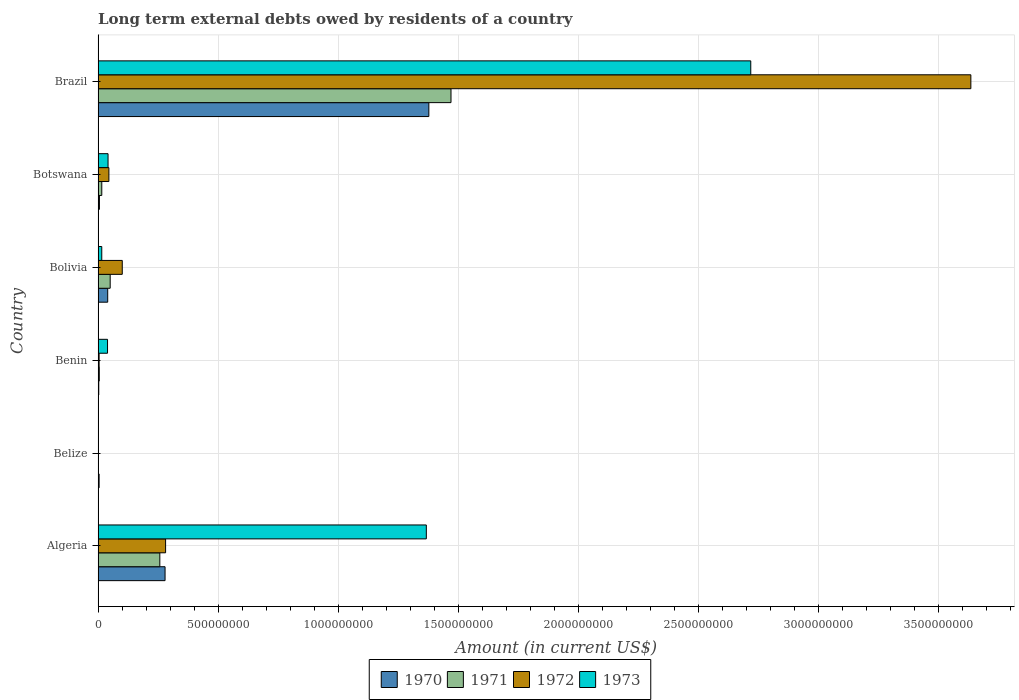Are the number of bars on each tick of the Y-axis equal?
Ensure brevity in your answer.  No. What is the label of the 4th group of bars from the top?
Your response must be concise. Benin. What is the amount of long-term external debts owed by residents in 1972 in Bolivia?
Your answer should be compact. 1.01e+08. Across all countries, what is the maximum amount of long-term external debts owed by residents in 1973?
Your answer should be very brief. 2.72e+09. What is the total amount of long-term external debts owed by residents in 1973 in the graph?
Your answer should be very brief. 4.18e+09. What is the difference between the amount of long-term external debts owed by residents in 1970 in Benin and that in Botswana?
Ensure brevity in your answer.  -2.70e+06. What is the difference between the amount of long-term external debts owed by residents in 1971 in Bolivia and the amount of long-term external debts owed by residents in 1972 in Algeria?
Ensure brevity in your answer.  -2.31e+08. What is the average amount of long-term external debts owed by residents in 1971 per country?
Offer a very short reply. 2.99e+08. What is the difference between the amount of long-term external debts owed by residents in 1970 and amount of long-term external debts owed by residents in 1971 in Benin?
Offer a terse response. -2.12e+06. What is the ratio of the amount of long-term external debts owed by residents in 1973 in Algeria to that in Benin?
Offer a very short reply. 34.74. What is the difference between the highest and the second highest amount of long-term external debts owed by residents in 1972?
Your response must be concise. 3.35e+09. What is the difference between the highest and the lowest amount of long-term external debts owed by residents in 1972?
Offer a very short reply. 3.63e+09. Is the sum of the amount of long-term external debts owed by residents in 1970 in Bolivia and Brazil greater than the maximum amount of long-term external debts owed by residents in 1972 across all countries?
Ensure brevity in your answer.  No. Is it the case that in every country, the sum of the amount of long-term external debts owed by residents in 1973 and amount of long-term external debts owed by residents in 1972 is greater than the sum of amount of long-term external debts owed by residents in 1970 and amount of long-term external debts owed by residents in 1971?
Offer a very short reply. No. Is it the case that in every country, the sum of the amount of long-term external debts owed by residents in 1973 and amount of long-term external debts owed by residents in 1970 is greater than the amount of long-term external debts owed by residents in 1972?
Your answer should be compact. No. How many bars are there?
Make the answer very short. 21. Are all the bars in the graph horizontal?
Make the answer very short. Yes. How many countries are there in the graph?
Provide a short and direct response. 6. What is the difference between two consecutive major ticks on the X-axis?
Provide a succinct answer. 5.00e+08. Does the graph contain any zero values?
Offer a very short reply. Yes. Where does the legend appear in the graph?
Make the answer very short. Bottom center. How many legend labels are there?
Provide a succinct answer. 4. What is the title of the graph?
Give a very brief answer. Long term external debts owed by residents of a country. What is the label or title of the X-axis?
Offer a terse response. Amount (in current US$). What is the label or title of the Y-axis?
Keep it short and to the point. Country. What is the Amount (in current US$) of 1970 in Algeria?
Give a very brief answer. 2.79e+08. What is the Amount (in current US$) of 1971 in Algeria?
Ensure brevity in your answer.  2.57e+08. What is the Amount (in current US$) in 1972 in Algeria?
Give a very brief answer. 2.81e+08. What is the Amount (in current US$) in 1973 in Algeria?
Provide a succinct answer. 1.37e+09. What is the Amount (in current US$) in 1970 in Belize?
Provide a succinct answer. 4.30e+06. What is the Amount (in current US$) of 1973 in Belize?
Your answer should be very brief. 0. What is the Amount (in current US$) in 1970 in Benin?
Keep it short and to the point. 2.87e+06. What is the Amount (in current US$) in 1971 in Benin?
Offer a terse response. 4.99e+06. What is the Amount (in current US$) in 1972 in Benin?
Your answer should be compact. 4.28e+06. What is the Amount (in current US$) of 1973 in Benin?
Your response must be concise. 3.93e+07. What is the Amount (in current US$) of 1970 in Bolivia?
Ensure brevity in your answer.  4.01e+07. What is the Amount (in current US$) in 1971 in Bolivia?
Provide a succinct answer. 5.04e+07. What is the Amount (in current US$) in 1972 in Bolivia?
Ensure brevity in your answer.  1.01e+08. What is the Amount (in current US$) in 1973 in Bolivia?
Make the answer very short. 1.53e+07. What is the Amount (in current US$) of 1970 in Botswana?
Provide a succinct answer. 5.57e+06. What is the Amount (in current US$) of 1971 in Botswana?
Offer a terse response. 1.54e+07. What is the Amount (in current US$) of 1972 in Botswana?
Offer a terse response. 4.50e+07. What is the Amount (in current US$) of 1973 in Botswana?
Make the answer very short. 4.15e+07. What is the Amount (in current US$) in 1970 in Brazil?
Your answer should be very brief. 1.38e+09. What is the Amount (in current US$) of 1971 in Brazil?
Provide a short and direct response. 1.47e+09. What is the Amount (in current US$) of 1972 in Brazil?
Your answer should be very brief. 3.63e+09. What is the Amount (in current US$) of 1973 in Brazil?
Your response must be concise. 2.72e+09. Across all countries, what is the maximum Amount (in current US$) in 1970?
Your answer should be very brief. 1.38e+09. Across all countries, what is the maximum Amount (in current US$) in 1971?
Give a very brief answer. 1.47e+09. Across all countries, what is the maximum Amount (in current US$) in 1972?
Your answer should be very brief. 3.63e+09. Across all countries, what is the maximum Amount (in current US$) in 1973?
Your answer should be very brief. 2.72e+09. Across all countries, what is the minimum Amount (in current US$) of 1970?
Keep it short and to the point. 2.87e+06. Across all countries, what is the minimum Amount (in current US$) in 1972?
Keep it short and to the point. 0. Across all countries, what is the minimum Amount (in current US$) of 1973?
Your answer should be compact. 0. What is the total Amount (in current US$) of 1970 in the graph?
Keep it short and to the point. 1.71e+09. What is the total Amount (in current US$) in 1971 in the graph?
Provide a succinct answer. 1.80e+09. What is the total Amount (in current US$) of 1972 in the graph?
Provide a short and direct response. 4.06e+09. What is the total Amount (in current US$) of 1973 in the graph?
Offer a very short reply. 4.18e+09. What is the difference between the Amount (in current US$) of 1970 in Algeria and that in Belize?
Keep it short and to the point. 2.74e+08. What is the difference between the Amount (in current US$) in 1970 in Algeria and that in Benin?
Your answer should be very brief. 2.76e+08. What is the difference between the Amount (in current US$) of 1971 in Algeria and that in Benin?
Your answer should be very brief. 2.52e+08. What is the difference between the Amount (in current US$) in 1972 in Algeria and that in Benin?
Your answer should be compact. 2.77e+08. What is the difference between the Amount (in current US$) in 1973 in Algeria and that in Benin?
Provide a succinct answer. 1.33e+09. What is the difference between the Amount (in current US$) of 1970 in Algeria and that in Bolivia?
Your answer should be very brief. 2.39e+08. What is the difference between the Amount (in current US$) in 1971 in Algeria and that in Bolivia?
Make the answer very short. 2.07e+08. What is the difference between the Amount (in current US$) in 1972 in Algeria and that in Bolivia?
Your response must be concise. 1.80e+08. What is the difference between the Amount (in current US$) of 1973 in Algeria and that in Bolivia?
Give a very brief answer. 1.35e+09. What is the difference between the Amount (in current US$) of 1970 in Algeria and that in Botswana?
Give a very brief answer. 2.73e+08. What is the difference between the Amount (in current US$) of 1971 in Algeria and that in Botswana?
Your answer should be compact. 2.42e+08. What is the difference between the Amount (in current US$) in 1972 in Algeria and that in Botswana?
Keep it short and to the point. 2.36e+08. What is the difference between the Amount (in current US$) of 1973 in Algeria and that in Botswana?
Ensure brevity in your answer.  1.32e+09. What is the difference between the Amount (in current US$) of 1970 in Algeria and that in Brazil?
Your response must be concise. -1.10e+09. What is the difference between the Amount (in current US$) of 1971 in Algeria and that in Brazil?
Offer a very short reply. -1.21e+09. What is the difference between the Amount (in current US$) in 1972 in Algeria and that in Brazil?
Give a very brief answer. -3.35e+09. What is the difference between the Amount (in current US$) in 1973 in Algeria and that in Brazil?
Ensure brevity in your answer.  -1.35e+09. What is the difference between the Amount (in current US$) in 1970 in Belize and that in Benin?
Offer a very short reply. 1.43e+06. What is the difference between the Amount (in current US$) of 1970 in Belize and that in Bolivia?
Give a very brief answer. -3.58e+07. What is the difference between the Amount (in current US$) of 1970 in Belize and that in Botswana?
Provide a succinct answer. -1.27e+06. What is the difference between the Amount (in current US$) of 1970 in Belize and that in Brazil?
Your answer should be very brief. -1.37e+09. What is the difference between the Amount (in current US$) in 1970 in Benin and that in Bolivia?
Ensure brevity in your answer.  -3.72e+07. What is the difference between the Amount (in current US$) in 1971 in Benin and that in Bolivia?
Make the answer very short. -4.54e+07. What is the difference between the Amount (in current US$) of 1972 in Benin and that in Bolivia?
Ensure brevity in your answer.  -9.64e+07. What is the difference between the Amount (in current US$) of 1973 in Benin and that in Bolivia?
Your answer should be very brief. 2.40e+07. What is the difference between the Amount (in current US$) in 1970 in Benin and that in Botswana?
Offer a very short reply. -2.70e+06. What is the difference between the Amount (in current US$) of 1971 in Benin and that in Botswana?
Ensure brevity in your answer.  -1.04e+07. What is the difference between the Amount (in current US$) of 1972 in Benin and that in Botswana?
Ensure brevity in your answer.  -4.07e+07. What is the difference between the Amount (in current US$) of 1973 in Benin and that in Botswana?
Make the answer very short. -2.15e+06. What is the difference between the Amount (in current US$) in 1970 in Benin and that in Brazil?
Your answer should be compact. -1.37e+09. What is the difference between the Amount (in current US$) of 1971 in Benin and that in Brazil?
Offer a very short reply. -1.46e+09. What is the difference between the Amount (in current US$) of 1972 in Benin and that in Brazil?
Offer a terse response. -3.63e+09. What is the difference between the Amount (in current US$) in 1973 in Benin and that in Brazil?
Your answer should be very brief. -2.68e+09. What is the difference between the Amount (in current US$) of 1970 in Bolivia and that in Botswana?
Make the answer very short. 3.45e+07. What is the difference between the Amount (in current US$) in 1971 in Bolivia and that in Botswana?
Your response must be concise. 3.50e+07. What is the difference between the Amount (in current US$) of 1972 in Bolivia and that in Botswana?
Your answer should be very brief. 5.57e+07. What is the difference between the Amount (in current US$) in 1973 in Bolivia and that in Botswana?
Your response must be concise. -2.62e+07. What is the difference between the Amount (in current US$) in 1970 in Bolivia and that in Brazil?
Offer a terse response. -1.34e+09. What is the difference between the Amount (in current US$) of 1971 in Bolivia and that in Brazil?
Make the answer very short. -1.42e+09. What is the difference between the Amount (in current US$) in 1972 in Bolivia and that in Brazil?
Ensure brevity in your answer.  -3.53e+09. What is the difference between the Amount (in current US$) in 1973 in Bolivia and that in Brazil?
Your response must be concise. -2.70e+09. What is the difference between the Amount (in current US$) in 1970 in Botswana and that in Brazil?
Ensure brevity in your answer.  -1.37e+09. What is the difference between the Amount (in current US$) in 1971 in Botswana and that in Brazil?
Your answer should be compact. -1.45e+09. What is the difference between the Amount (in current US$) of 1972 in Botswana and that in Brazil?
Offer a very short reply. -3.59e+09. What is the difference between the Amount (in current US$) in 1973 in Botswana and that in Brazil?
Your response must be concise. -2.68e+09. What is the difference between the Amount (in current US$) in 1970 in Algeria and the Amount (in current US$) in 1971 in Benin?
Offer a terse response. 2.74e+08. What is the difference between the Amount (in current US$) of 1970 in Algeria and the Amount (in current US$) of 1972 in Benin?
Provide a succinct answer. 2.75e+08. What is the difference between the Amount (in current US$) of 1970 in Algeria and the Amount (in current US$) of 1973 in Benin?
Your response must be concise. 2.39e+08. What is the difference between the Amount (in current US$) of 1971 in Algeria and the Amount (in current US$) of 1972 in Benin?
Your answer should be compact. 2.53e+08. What is the difference between the Amount (in current US$) of 1971 in Algeria and the Amount (in current US$) of 1973 in Benin?
Provide a short and direct response. 2.18e+08. What is the difference between the Amount (in current US$) in 1972 in Algeria and the Amount (in current US$) in 1973 in Benin?
Provide a succinct answer. 2.42e+08. What is the difference between the Amount (in current US$) in 1970 in Algeria and the Amount (in current US$) in 1971 in Bolivia?
Make the answer very short. 2.28e+08. What is the difference between the Amount (in current US$) in 1970 in Algeria and the Amount (in current US$) in 1972 in Bolivia?
Make the answer very short. 1.78e+08. What is the difference between the Amount (in current US$) in 1970 in Algeria and the Amount (in current US$) in 1973 in Bolivia?
Offer a very short reply. 2.63e+08. What is the difference between the Amount (in current US$) of 1971 in Algeria and the Amount (in current US$) of 1972 in Bolivia?
Your response must be concise. 1.56e+08. What is the difference between the Amount (in current US$) in 1971 in Algeria and the Amount (in current US$) in 1973 in Bolivia?
Keep it short and to the point. 2.42e+08. What is the difference between the Amount (in current US$) of 1972 in Algeria and the Amount (in current US$) of 1973 in Bolivia?
Your answer should be very brief. 2.66e+08. What is the difference between the Amount (in current US$) of 1970 in Algeria and the Amount (in current US$) of 1971 in Botswana?
Provide a succinct answer. 2.63e+08. What is the difference between the Amount (in current US$) in 1970 in Algeria and the Amount (in current US$) in 1972 in Botswana?
Provide a succinct answer. 2.34e+08. What is the difference between the Amount (in current US$) in 1970 in Algeria and the Amount (in current US$) in 1973 in Botswana?
Your response must be concise. 2.37e+08. What is the difference between the Amount (in current US$) in 1971 in Algeria and the Amount (in current US$) in 1972 in Botswana?
Give a very brief answer. 2.12e+08. What is the difference between the Amount (in current US$) of 1971 in Algeria and the Amount (in current US$) of 1973 in Botswana?
Offer a terse response. 2.16e+08. What is the difference between the Amount (in current US$) in 1972 in Algeria and the Amount (in current US$) in 1973 in Botswana?
Make the answer very short. 2.40e+08. What is the difference between the Amount (in current US$) of 1970 in Algeria and the Amount (in current US$) of 1971 in Brazil?
Your answer should be very brief. -1.19e+09. What is the difference between the Amount (in current US$) in 1970 in Algeria and the Amount (in current US$) in 1972 in Brazil?
Offer a terse response. -3.35e+09. What is the difference between the Amount (in current US$) of 1970 in Algeria and the Amount (in current US$) of 1973 in Brazil?
Provide a short and direct response. -2.44e+09. What is the difference between the Amount (in current US$) in 1971 in Algeria and the Amount (in current US$) in 1972 in Brazil?
Your response must be concise. -3.38e+09. What is the difference between the Amount (in current US$) of 1971 in Algeria and the Amount (in current US$) of 1973 in Brazil?
Provide a short and direct response. -2.46e+09. What is the difference between the Amount (in current US$) of 1972 in Algeria and the Amount (in current US$) of 1973 in Brazil?
Offer a terse response. -2.44e+09. What is the difference between the Amount (in current US$) in 1970 in Belize and the Amount (in current US$) in 1971 in Benin?
Keep it short and to the point. -6.88e+05. What is the difference between the Amount (in current US$) of 1970 in Belize and the Amount (in current US$) of 1972 in Benin?
Provide a succinct answer. 2.40e+04. What is the difference between the Amount (in current US$) in 1970 in Belize and the Amount (in current US$) in 1973 in Benin?
Make the answer very short. -3.50e+07. What is the difference between the Amount (in current US$) in 1970 in Belize and the Amount (in current US$) in 1971 in Bolivia?
Your response must be concise. -4.61e+07. What is the difference between the Amount (in current US$) in 1970 in Belize and the Amount (in current US$) in 1972 in Bolivia?
Provide a short and direct response. -9.63e+07. What is the difference between the Amount (in current US$) in 1970 in Belize and the Amount (in current US$) in 1973 in Bolivia?
Your answer should be very brief. -1.10e+07. What is the difference between the Amount (in current US$) of 1970 in Belize and the Amount (in current US$) of 1971 in Botswana?
Offer a very short reply. -1.11e+07. What is the difference between the Amount (in current US$) in 1970 in Belize and the Amount (in current US$) in 1972 in Botswana?
Your answer should be compact. -4.07e+07. What is the difference between the Amount (in current US$) in 1970 in Belize and the Amount (in current US$) in 1973 in Botswana?
Make the answer very short. -3.72e+07. What is the difference between the Amount (in current US$) of 1970 in Belize and the Amount (in current US$) of 1971 in Brazil?
Your response must be concise. -1.46e+09. What is the difference between the Amount (in current US$) of 1970 in Belize and the Amount (in current US$) of 1972 in Brazil?
Ensure brevity in your answer.  -3.63e+09. What is the difference between the Amount (in current US$) of 1970 in Belize and the Amount (in current US$) of 1973 in Brazil?
Provide a succinct answer. -2.71e+09. What is the difference between the Amount (in current US$) of 1970 in Benin and the Amount (in current US$) of 1971 in Bolivia?
Your answer should be very brief. -4.75e+07. What is the difference between the Amount (in current US$) in 1970 in Benin and the Amount (in current US$) in 1972 in Bolivia?
Offer a terse response. -9.78e+07. What is the difference between the Amount (in current US$) in 1970 in Benin and the Amount (in current US$) in 1973 in Bolivia?
Ensure brevity in your answer.  -1.24e+07. What is the difference between the Amount (in current US$) in 1971 in Benin and the Amount (in current US$) in 1972 in Bolivia?
Ensure brevity in your answer.  -9.57e+07. What is the difference between the Amount (in current US$) of 1971 in Benin and the Amount (in current US$) of 1973 in Bolivia?
Provide a succinct answer. -1.03e+07. What is the difference between the Amount (in current US$) of 1972 in Benin and the Amount (in current US$) of 1973 in Bolivia?
Offer a terse response. -1.10e+07. What is the difference between the Amount (in current US$) in 1970 in Benin and the Amount (in current US$) in 1971 in Botswana?
Your answer should be very brief. -1.25e+07. What is the difference between the Amount (in current US$) in 1970 in Benin and the Amount (in current US$) in 1972 in Botswana?
Provide a short and direct response. -4.21e+07. What is the difference between the Amount (in current US$) in 1970 in Benin and the Amount (in current US$) in 1973 in Botswana?
Your response must be concise. -3.86e+07. What is the difference between the Amount (in current US$) in 1971 in Benin and the Amount (in current US$) in 1972 in Botswana?
Your answer should be very brief. -4.00e+07. What is the difference between the Amount (in current US$) of 1971 in Benin and the Amount (in current US$) of 1973 in Botswana?
Offer a very short reply. -3.65e+07. What is the difference between the Amount (in current US$) in 1972 in Benin and the Amount (in current US$) in 1973 in Botswana?
Your answer should be very brief. -3.72e+07. What is the difference between the Amount (in current US$) in 1970 in Benin and the Amount (in current US$) in 1971 in Brazil?
Make the answer very short. -1.47e+09. What is the difference between the Amount (in current US$) of 1970 in Benin and the Amount (in current US$) of 1972 in Brazil?
Ensure brevity in your answer.  -3.63e+09. What is the difference between the Amount (in current US$) of 1970 in Benin and the Amount (in current US$) of 1973 in Brazil?
Make the answer very short. -2.71e+09. What is the difference between the Amount (in current US$) of 1971 in Benin and the Amount (in current US$) of 1972 in Brazil?
Give a very brief answer. -3.63e+09. What is the difference between the Amount (in current US$) of 1971 in Benin and the Amount (in current US$) of 1973 in Brazil?
Your answer should be compact. -2.71e+09. What is the difference between the Amount (in current US$) in 1972 in Benin and the Amount (in current US$) in 1973 in Brazil?
Offer a very short reply. -2.71e+09. What is the difference between the Amount (in current US$) in 1970 in Bolivia and the Amount (in current US$) in 1971 in Botswana?
Your answer should be very brief. 2.47e+07. What is the difference between the Amount (in current US$) in 1970 in Bolivia and the Amount (in current US$) in 1972 in Botswana?
Give a very brief answer. -4.88e+06. What is the difference between the Amount (in current US$) in 1970 in Bolivia and the Amount (in current US$) in 1973 in Botswana?
Provide a short and direct response. -1.40e+06. What is the difference between the Amount (in current US$) of 1971 in Bolivia and the Amount (in current US$) of 1972 in Botswana?
Keep it short and to the point. 5.46e+06. What is the difference between the Amount (in current US$) in 1971 in Bolivia and the Amount (in current US$) in 1973 in Botswana?
Provide a short and direct response. 8.94e+06. What is the difference between the Amount (in current US$) of 1972 in Bolivia and the Amount (in current US$) of 1973 in Botswana?
Your answer should be very brief. 5.92e+07. What is the difference between the Amount (in current US$) of 1970 in Bolivia and the Amount (in current US$) of 1971 in Brazil?
Provide a succinct answer. -1.43e+09. What is the difference between the Amount (in current US$) in 1970 in Bolivia and the Amount (in current US$) in 1972 in Brazil?
Provide a succinct answer. -3.59e+09. What is the difference between the Amount (in current US$) of 1970 in Bolivia and the Amount (in current US$) of 1973 in Brazil?
Your answer should be very brief. -2.68e+09. What is the difference between the Amount (in current US$) in 1971 in Bolivia and the Amount (in current US$) in 1972 in Brazil?
Offer a terse response. -3.58e+09. What is the difference between the Amount (in current US$) in 1971 in Bolivia and the Amount (in current US$) in 1973 in Brazil?
Offer a very short reply. -2.67e+09. What is the difference between the Amount (in current US$) of 1972 in Bolivia and the Amount (in current US$) of 1973 in Brazil?
Offer a terse response. -2.62e+09. What is the difference between the Amount (in current US$) of 1970 in Botswana and the Amount (in current US$) of 1971 in Brazil?
Offer a very short reply. -1.46e+09. What is the difference between the Amount (in current US$) in 1970 in Botswana and the Amount (in current US$) in 1972 in Brazil?
Give a very brief answer. -3.63e+09. What is the difference between the Amount (in current US$) of 1970 in Botswana and the Amount (in current US$) of 1973 in Brazil?
Your answer should be compact. -2.71e+09. What is the difference between the Amount (in current US$) in 1971 in Botswana and the Amount (in current US$) in 1972 in Brazil?
Provide a succinct answer. -3.62e+09. What is the difference between the Amount (in current US$) of 1971 in Botswana and the Amount (in current US$) of 1973 in Brazil?
Offer a terse response. -2.70e+09. What is the difference between the Amount (in current US$) in 1972 in Botswana and the Amount (in current US$) in 1973 in Brazil?
Your response must be concise. -2.67e+09. What is the average Amount (in current US$) of 1970 per country?
Your answer should be very brief. 2.85e+08. What is the average Amount (in current US$) of 1971 per country?
Your response must be concise. 2.99e+08. What is the average Amount (in current US$) of 1972 per country?
Offer a terse response. 6.77e+08. What is the average Amount (in current US$) in 1973 per country?
Your answer should be very brief. 6.97e+08. What is the difference between the Amount (in current US$) of 1970 and Amount (in current US$) of 1971 in Algeria?
Give a very brief answer. 2.18e+07. What is the difference between the Amount (in current US$) in 1970 and Amount (in current US$) in 1972 in Algeria?
Offer a terse response. -2.27e+06. What is the difference between the Amount (in current US$) of 1970 and Amount (in current US$) of 1973 in Algeria?
Provide a short and direct response. -1.09e+09. What is the difference between the Amount (in current US$) in 1971 and Amount (in current US$) in 1972 in Algeria?
Ensure brevity in your answer.  -2.41e+07. What is the difference between the Amount (in current US$) in 1971 and Amount (in current US$) in 1973 in Algeria?
Keep it short and to the point. -1.11e+09. What is the difference between the Amount (in current US$) of 1972 and Amount (in current US$) of 1973 in Algeria?
Ensure brevity in your answer.  -1.09e+09. What is the difference between the Amount (in current US$) in 1970 and Amount (in current US$) in 1971 in Benin?
Offer a very short reply. -2.12e+06. What is the difference between the Amount (in current US$) in 1970 and Amount (in current US$) in 1972 in Benin?
Give a very brief answer. -1.41e+06. What is the difference between the Amount (in current US$) in 1970 and Amount (in current US$) in 1973 in Benin?
Make the answer very short. -3.65e+07. What is the difference between the Amount (in current US$) of 1971 and Amount (in current US$) of 1972 in Benin?
Your response must be concise. 7.12e+05. What is the difference between the Amount (in current US$) in 1971 and Amount (in current US$) in 1973 in Benin?
Provide a short and direct response. -3.43e+07. What is the difference between the Amount (in current US$) of 1972 and Amount (in current US$) of 1973 in Benin?
Offer a very short reply. -3.51e+07. What is the difference between the Amount (in current US$) of 1970 and Amount (in current US$) of 1971 in Bolivia?
Make the answer very short. -1.03e+07. What is the difference between the Amount (in current US$) of 1970 and Amount (in current US$) of 1972 in Bolivia?
Ensure brevity in your answer.  -6.06e+07. What is the difference between the Amount (in current US$) of 1970 and Amount (in current US$) of 1973 in Bolivia?
Give a very brief answer. 2.48e+07. What is the difference between the Amount (in current US$) of 1971 and Amount (in current US$) of 1972 in Bolivia?
Make the answer very short. -5.02e+07. What is the difference between the Amount (in current US$) of 1971 and Amount (in current US$) of 1973 in Bolivia?
Offer a very short reply. 3.51e+07. What is the difference between the Amount (in current US$) in 1972 and Amount (in current US$) in 1973 in Bolivia?
Your answer should be compact. 8.53e+07. What is the difference between the Amount (in current US$) in 1970 and Amount (in current US$) in 1971 in Botswana?
Offer a terse response. -9.82e+06. What is the difference between the Amount (in current US$) of 1970 and Amount (in current US$) of 1972 in Botswana?
Ensure brevity in your answer.  -3.94e+07. What is the difference between the Amount (in current US$) in 1970 and Amount (in current US$) in 1973 in Botswana?
Offer a terse response. -3.59e+07. What is the difference between the Amount (in current US$) in 1971 and Amount (in current US$) in 1972 in Botswana?
Make the answer very short. -2.96e+07. What is the difference between the Amount (in current US$) of 1971 and Amount (in current US$) of 1973 in Botswana?
Provide a short and direct response. -2.61e+07. What is the difference between the Amount (in current US$) of 1972 and Amount (in current US$) of 1973 in Botswana?
Give a very brief answer. 3.47e+06. What is the difference between the Amount (in current US$) in 1970 and Amount (in current US$) in 1971 in Brazil?
Keep it short and to the point. -9.22e+07. What is the difference between the Amount (in current US$) in 1970 and Amount (in current US$) in 1972 in Brazil?
Your answer should be compact. -2.26e+09. What is the difference between the Amount (in current US$) of 1970 and Amount (in current US$) of 1973 in Brazil?
Give a very brief answer. -1.34e+09. What is the difference between the Amount (in current US$) in 1971 and Amount (in current US$) in 1972 in Brazil?
Provide a short and direct response. -2.16e+09. What is the difference between the Amount (in current US$) in 1971 and Amount (in current US$) in 1973 in Brazil?
Offer a very short reply. -1.25e+09. What is the difference between the Amount (in current US$) in 1972 and Amount (in current US$) in 1973 in Brazil?
Give a very brief answer. 9.16e+08. What is the ratio of the Amount (in current US$) of 1970 in Algeria to that in Belize?
Keep it short and to the point. 64.82. What is the ratio of the Amount (in current US$) in 1970 in Algeria to that in Benin?
Your answer should be compact. 97.24. What is the ratio of the Amount (in current US$) of 1971 in Algeria to that in Benin?
Your answer should be very brief. 51.51. What is the ratio of the Amount (in current US$) of 1972 in Algeria to that in Benin?
Provide a succinct answer. 65.71. What is the ratio of the Amount (in current US$) in 1973 in Algeria to that in Benin?
Your answer should be very brief. 34.74. What is the ratio of the Amount (in current US$) in 1970 in Algeria to that in Bolivia?
Offer a terse response. 6.96. What is the ratio of the Amount (in current US$) in 1971 in Algeria to that in Bolivia?
Provide a short and direct response. 5.1. What is the ratio of the Amount (in current US$) in 1972 in Algeria to that in Bolivia?
Ensure brevity in your answer.  2.79. What is the ratio of the Amount (in current US$) of 1973 in Algeria to that in Bolivia?
Give a very brief answer. 89.32. What is the ratio of the Amount (in current US$) of 1970 in Algeria to that in Botswana?
Give a very brief answer. 50.08. What is the ratio of the Amount (in current US$) in 1971 in Algeria to that in Botswana?
Provide a short and direct response. 16.7. What is the ratio of the Amount (in current US$) of 1972 in Algeria to that in Botswana?
Your answer should be compact. 6.25. What is the ratio of the Amount (in current US$) of 1973 in Algeria to that in Botswana?
Give a very brief answer. 32.94. What is the ratio of the Amount (in current US$) of 1970 in Algeria to that in Brazil?
Provide a succinct answer. 0.2. What is the ratio of the Amount (in current US$) in 1971 in Algeria to that in Brazil?
Your answer should be very brief. 0.17. What is the ratio of the Amount (in current US$) in 1972 in Algeria to that in Brazil?
Keep it short and to the point. 0.08. What is the ratio of the Amount (in current US$) in 1973 in Algeria to that in Brazil?
Offer a very short reply. 0.5. What is the ratio of the Amount (in current US$) in 1970 in Belize to that in Benin?
Your answer should be very brief. 1.5. What is the ratio of the Amount (in current US$) of 1970 in Belize to that in Bolivia?
Your response must be concise. 0.11. What is the ratio of the Amount (in current US$) of 1970 in Belize to that in Botswana?
Provide a succinct answer. 0.77. What is the ratio of the Amount (in current US$) of 1970 in Belize to that in Brazil?
Your response must be concise. 0. What is the ratio of the Amount (in current US$) of 1970 in Benin to that in Bolivia?
Give a very brief answer. 0.07. What is the ratio of the Amount (in current US$) of 1971 in Benin to that in Bolivia?
Ensure brevity in your answer.  0.1. What is the ratio of the Amount (in current US$) of 1972 in Benin to that in Bolivia?
Ensure brevity in your answer.  0.04. What is the ratio of the Amount (in current US$) of 1973 in Benin to that in Bolivia?
Provide a short and direct response. 2.57. What is the ratio of the Amount (in current US$) of 1970 in Benin to that in Botswana?
Your response must be concise. 0.52. What is the ratio of the Amount (in current US$) in 1971 in Benin to that in Botswana?
Your answer should be compact. 0.32. What is the ratio of the Amount (in current US$) of 1972 in Benin to that in Botswana?
Your answer should be very brief. 0.1. What is the ratio of the Amount (in current US$) of 1973 in Benin to that in Botswana?
Provide a short and direct response. 0.95. What is the ratio of the Amount (in current US$) in 1970 in Benin to that in Brazil?
Make the answer very short. 0. What is the ratio of the Amount (in current US$) of 1971 in Benin to that in Brazil?
Give a very brief answer. 0. What is the ratio of the Amount (in current US$) of 1972 in Benin to that in Brazil?
Your answer should be compact. 0. What is the ratio of the Amount (in current US$) of 1973 in Benin to that in Brazil?
Your answer should be compact. 0.01. What is the ratio of the Amount (in current US$) in 1970 in Bolivia to that in Botswana?
Keep it short and to the point. 7.2. What is the ratio of the Amount (in current US$) of 1971 in Bolivia to that in Botswana?
Offer a very short reply. 3.28. What is the ratio of the Amount (in current US$) of 1972 in Bolivia to that in Botswana?
Give a very brief answer. 2.24. What is the ratio of the Amount (in current US$) of 1973 in Bolivia to that in Botswana?
Make the answer very short. 0.37. What is the ratio of the Amount (in current US$) of 1970 in Bolivia to that in Brazil?
Offer a very short reply. 0.03. What is the ratio of the Amount (in current US$) of 1971 in Bolivia to that in Brazil?
Your answer should be compact. 0.03. What is the ratio of the Amount (in current US$) in 1972 in Bolivia to that in Brazil?
Offer a terse response. 0.03. What is the ratio of the Amount (in current US$) of 1973 in Bolivia to that in Brazil?
Provide a short and direct response. 0.01. What is the ratio of the Amount (in current US$) of 1970 in Botswana to that in Brazil?
Keep it short and to the point. 0. What is the ratio of the Amount (in current US$) in 1971 in Botswana to that in Brazil?
Your answer should be very brief. 0.01. What is the ratio of the Amount (in current US$) in 1972 in Botswana to that in Brazil?
Ensure brevity in your answer.  0.01. What is the ratio of the Amount (in current US$) of 1973 in Botswana to that in Brazil?
Your response must be concise. 0.02. What is the difference between the highest and the second highest Amount (in current US$) of 1970?
Provide a short and direct response. 1.10e+09. What is the difference between the highest and the second highest Amount (in current US$) of 1971?
Make the answer very short. 1.21e+09. What is the difference between the highest and the second highest Amount (in current US$) in 1972?
Offer a terse response. 3.35e+09. What is the difference between the highest and the second highest Amount (in current US$) of 1973?
Your response must be concise. 1.35e+09. What is the difference between the highest and the lowest Amount (in current US$) in 1970?
Make the answer very short. 1.37e+09. What is the difference between the highest and the lowest Amount (in current US$) in 1971?
Make the answer very short. 1.47e+09. What is the difference between the highest and the lowest Amount (in current US$) of 1972?
Offer a terse response. 3.63e+09. What is the difference between the highest and the lowest Amount (in current US$) of 1973?
Give a very brief answer. 2.72e+09. 